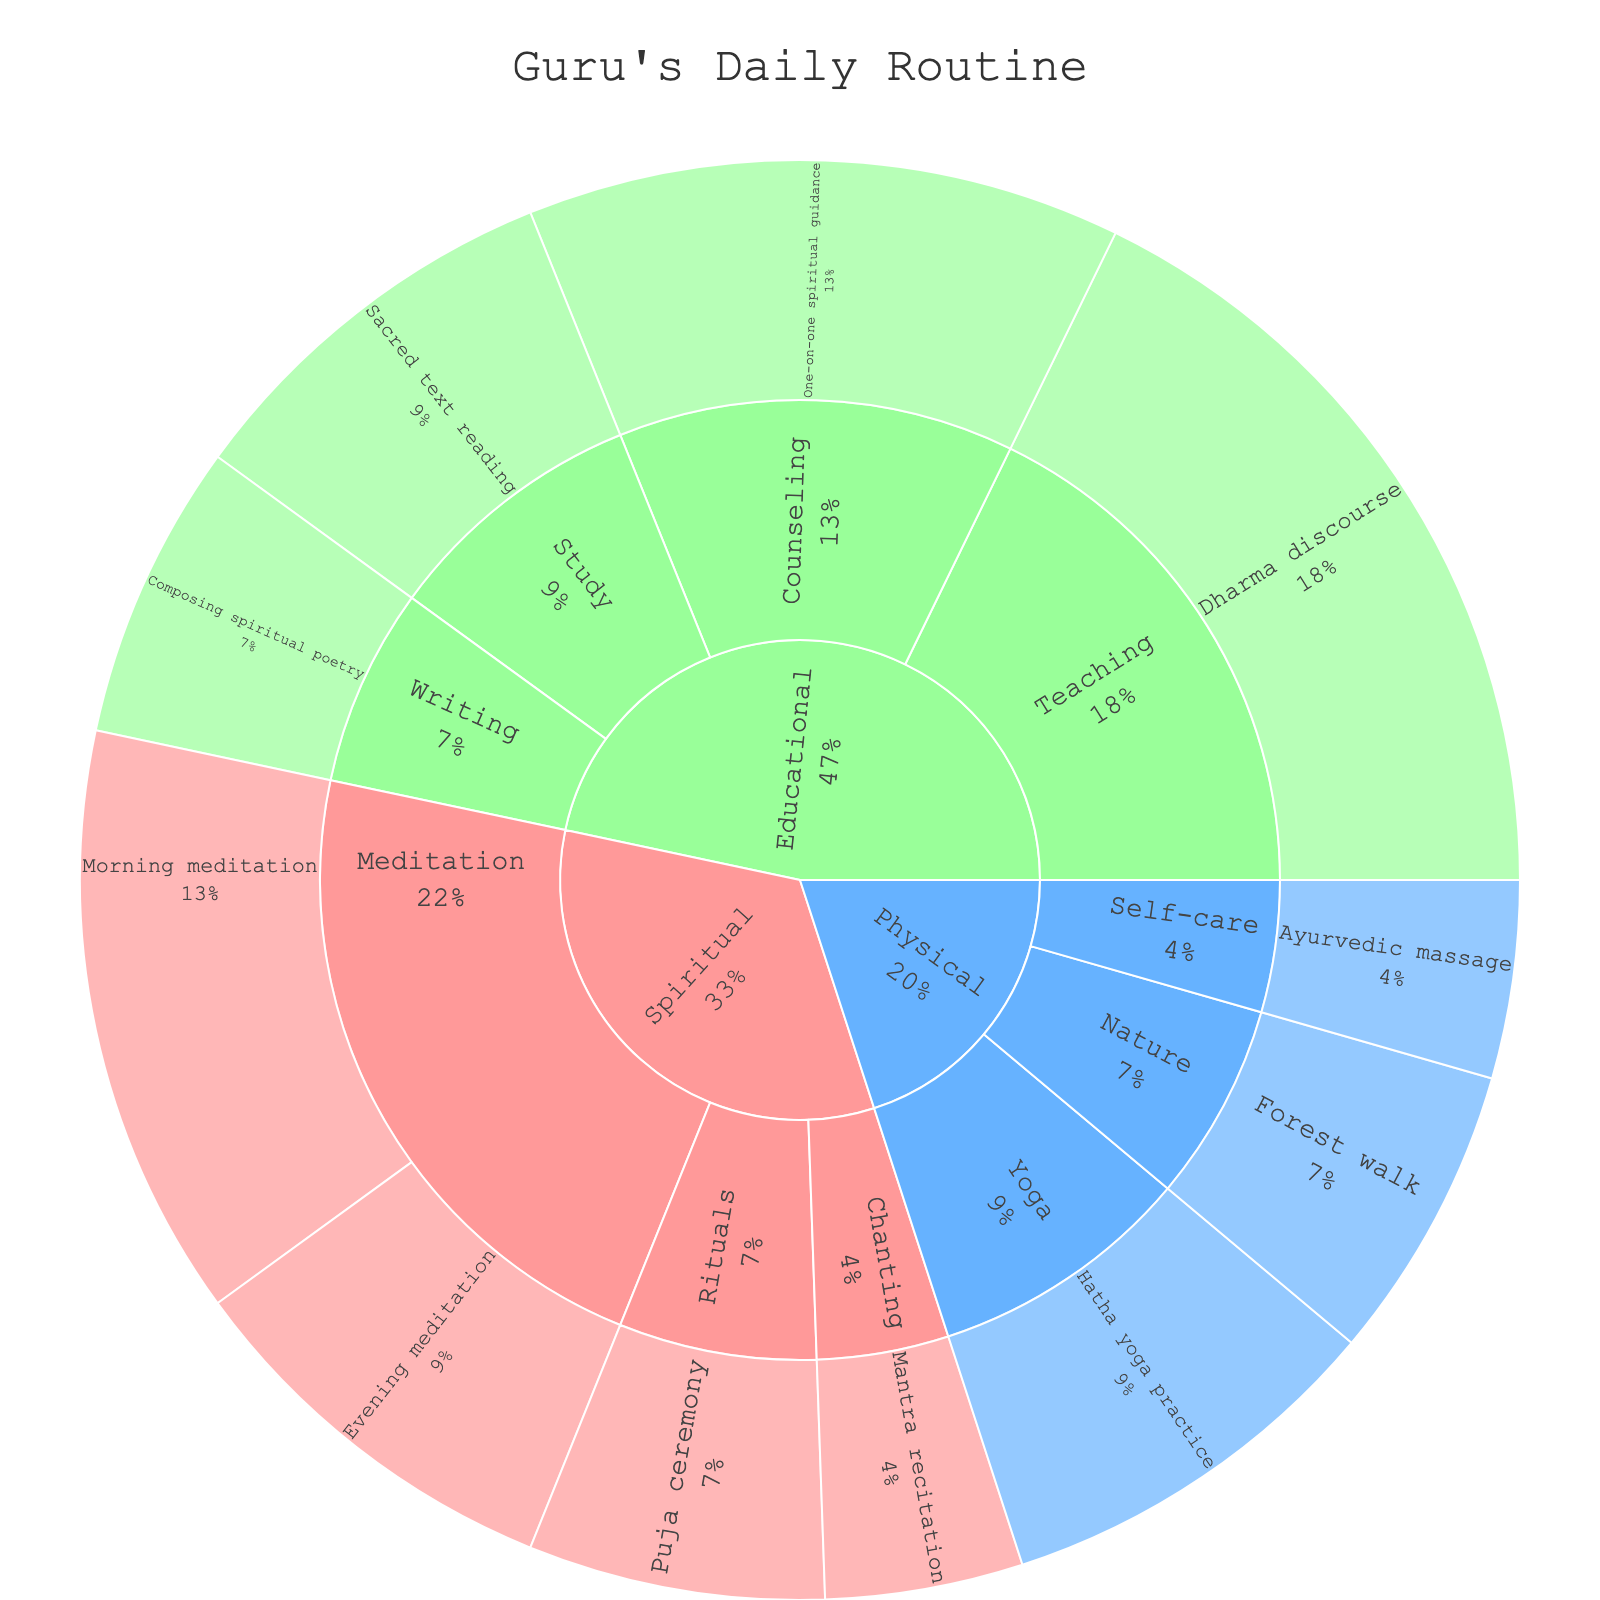What's the title of the figure? The title is typically displayed at the top of the figure, and it provides an overview of what the chart represents. In this case, the figure is about the daily routine of a guru, as the information mentions.
Answer: Guru's Daily Routine Which activity has the longest duration? To determine the longest duration, find the activity with the highest numerical value for duration in the segments of the sunburst plot. Checking the data, 'Dharma discourse' has 120 minutes.
Answer: Dharma discourse How much time does the Guru spend on spiritual activities? To calculate the total time spent on spiritual activities, sum the duration of all activities under the "Spiritual" category: Morning meditation (90) + Evening meditation (60) + Puja ceremony (45) + Mantra recitation (30).
Answer: 225 minutes Which category occupies the largest segment in the sunburst plot? The largest segment in a sunburst plot can be identified by comparing the overall size of each primary color-coded segment. Since 'Educational' includes activities like Dharma discourse (120), Sacred text reading (60), One-on-one spiritual guidance (90), and more, summing these will show it has the largest duration.
Answer: Educational What percentage of the Guru's day is spent on physical activities? Calculate the total duration of physical activities: Hatha yoga practice (60) + Forest walk (45) + Ayurvedic massage (30) = 135 minutes. Then divide by the total duration of the day (total of all activities) and multiply by 100. Summing the data, 225 (Spiritual) + 135 (Physical) + 315 (Educational) = 675. (135/675)*100 = 20%.
Answer: 20% How does the time spent on meditation compare to the time spent on yoga? Compare the sum of durations for activities categorized under 'Meditation' to the 'Yoga' subcategory. Meditation: Morning meditation (90) + Evening meditation (60) = 150 minutes. Yoga: Hatha yoga practice (60) = 60 minutes.
Answer: Meditation: 150 minutes, Yoga: 60 minutes What is the duration difference between the longest and shortest spiritual activities? Identify the longest (Morning meditation, 90 minutes) and the shortest (Mantra recitation, 30 minutes) activities under the 'Spiritual' category and subtract the duration of the shortest from the longest.
Answer: 60 minutes What's the average duration of the educational activities? Sum the durations of all educational activities: Dharma discourse (120) + Sacred text reading (60) + One-on-one spiritual guidance (90) + Composing spiritual poetry (45) = 315 minutes. Divide by the number of activities in the category (4).
Answer: 78.75 minutes 